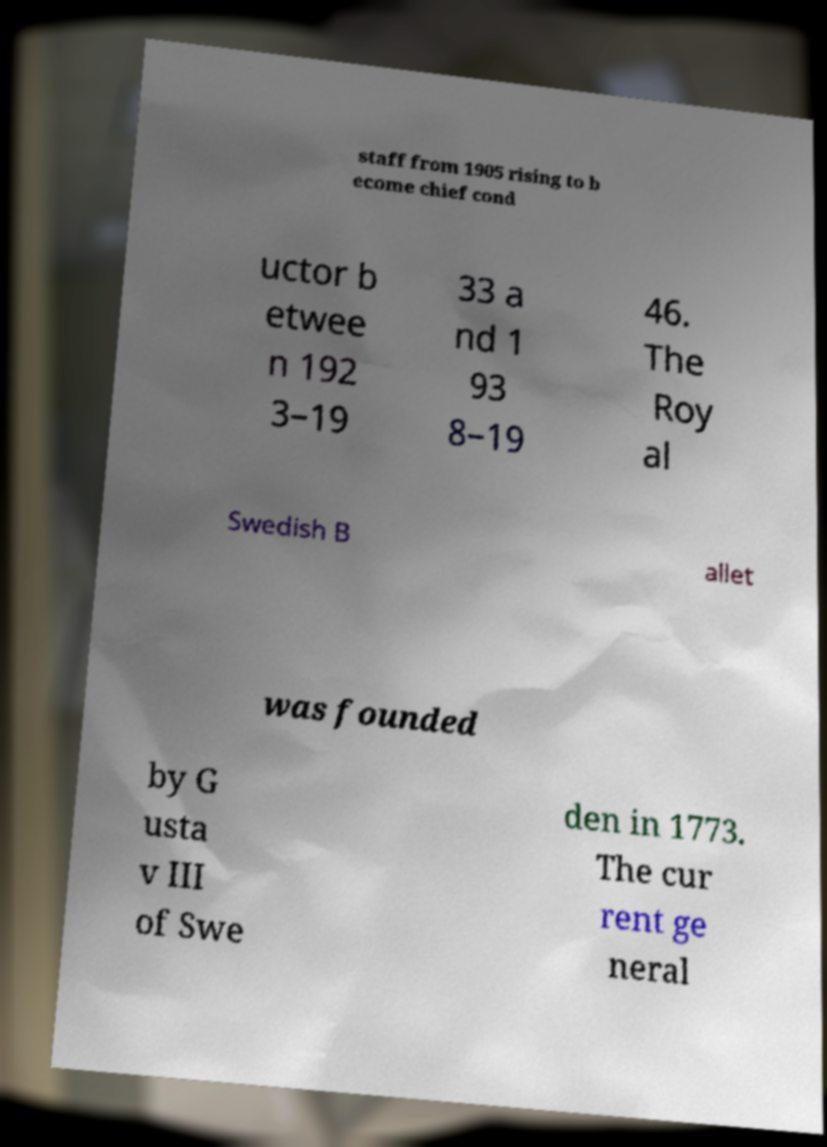Can you accurately transcribe the text from the provided image for me? staff from 1905 rising to b ecome chief cond uctor b etwee n 192 3–19 33 a nd 1 93 8–19 46. The Roy al Swedish B allet was founded by G usta v III of Swe den in 1773. The cur rent ge neral 